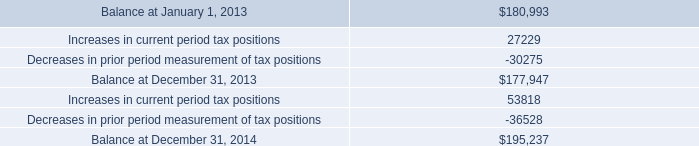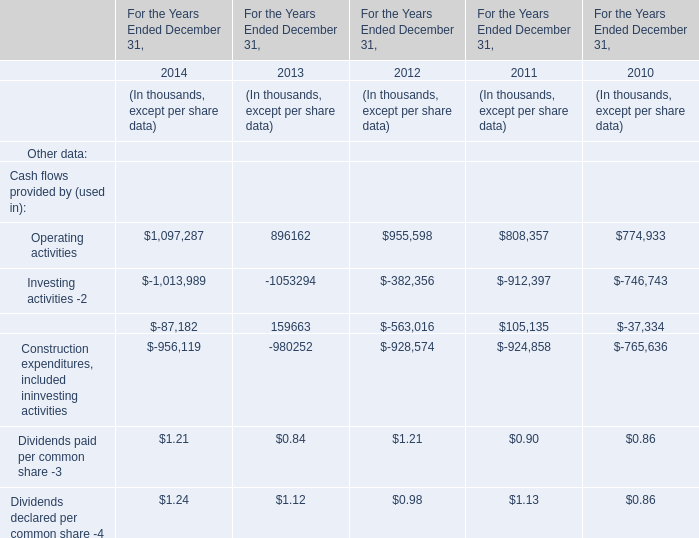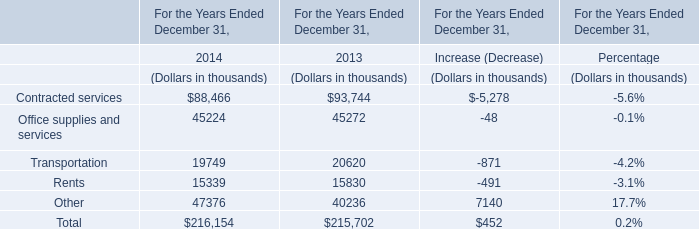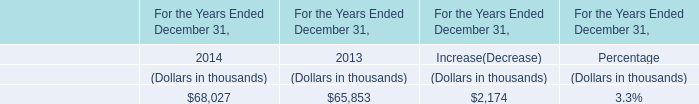What's the total amount of Cash flows provided by (used in) in 2014? (in thousand) 
Computations: (((((1097287 - 1013989) - 87182) - 956119) + 1.21) + 1.24)
Answer: -960000.55. 